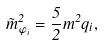<formula> <loc_0><loc_0><loc_500><loc_500>\tilde { m } _ { \varphi _ { i } } ^ { 2 } = \frac { 5 } { 2 } m ^ { 2 } q _ { i } ,</formula> 